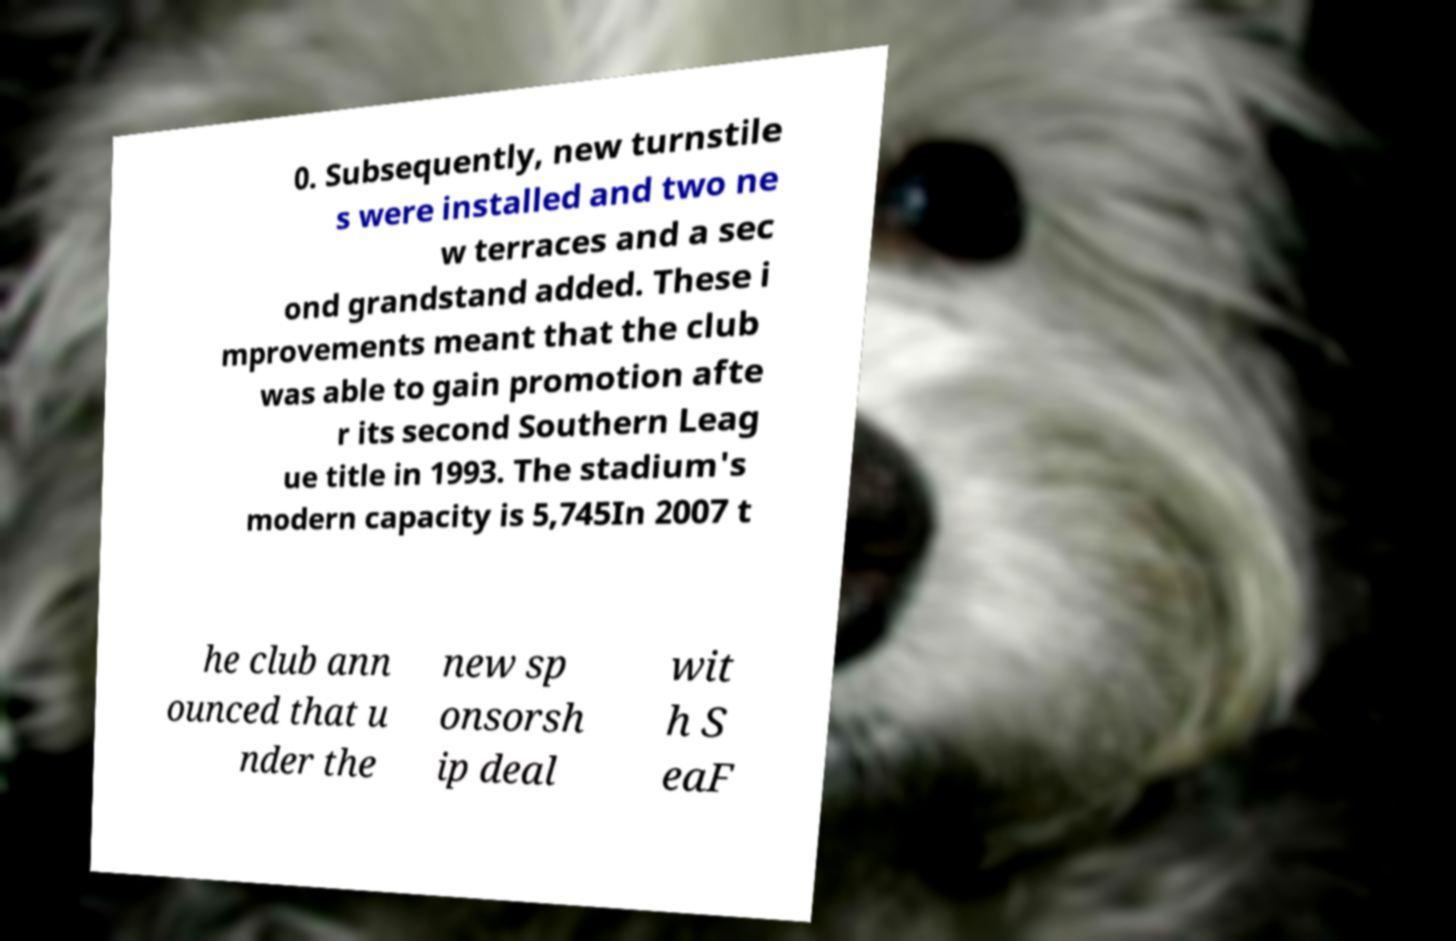Can you read and provide the text displayed in the image?This photo seems to have some interesting text. Can you extract and type it out for me? 0. Subsequently, new turnstile s were installed and two ne w terraces and a sec ond grandstand added. These i mprovements meant that the club was able to gain promotion afte r its second Southern Leag ue title in 1993. The stadium's modern capacity is 5,745In 2007 t he club ann ounced that u nder the new sp onsorsh ip deal wit h S eaF 